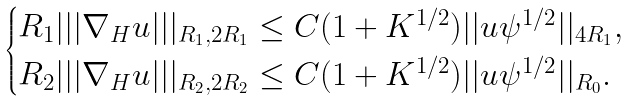<formula> <loc_0><loc_0><loc_500><loc_500>\begin{cases} R _ { 1 } | | | \nabla _ { H } u | | | _ { R _ { 1 } , 2 R _ { 1 } } \leq C ( 1 + K ^ { 1 / 2 } ) | | u \psi ^ { 1 / 2 } | | _ { 4 R _ { 1 } } , \\ R _ { 2 } | | | \nabla _ { H } u | | | _ { R _ { 2 } , 2 R _ { 2 } } \leq C ( 1 + K ^ { 1 / 2 } ) | | u \psi ^ { 1 / 2 } | | _ { R _ { 0 } } . \end{cases}</formula> 